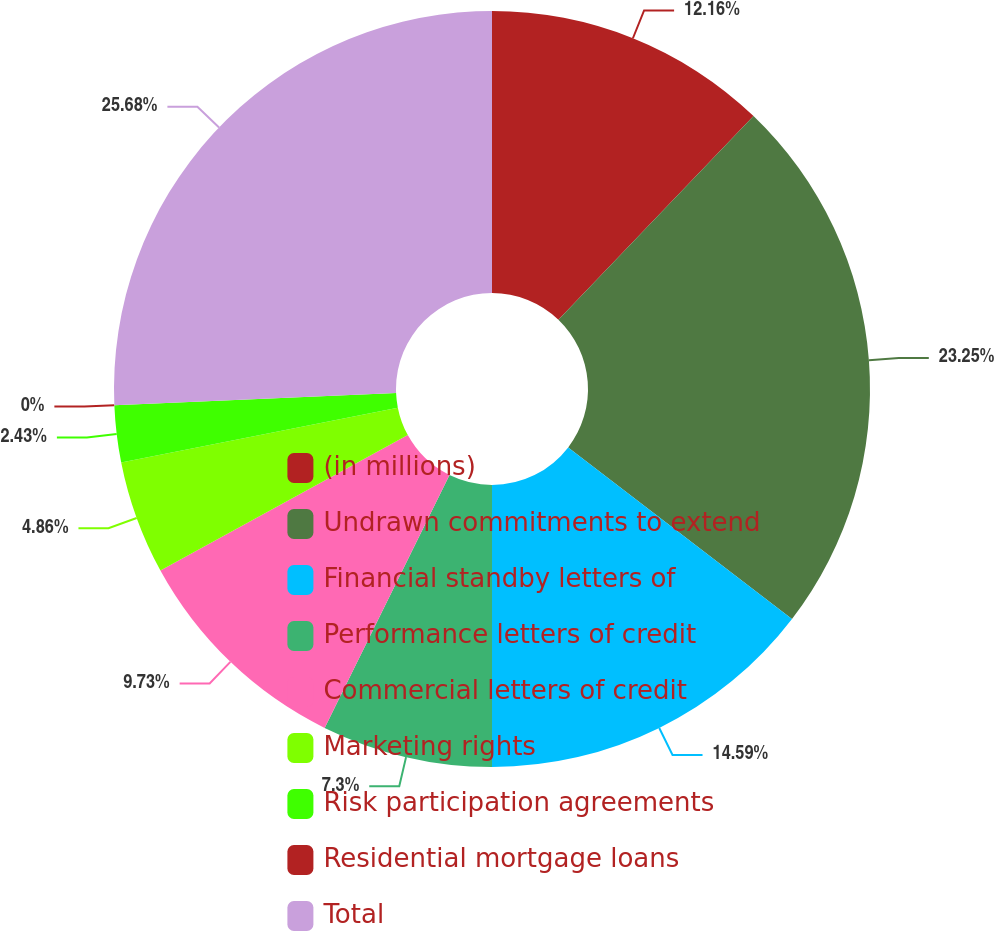<chart> <loc_0><loc_0><loc_500><loc_500><pie_chart><fcel>(in millions)<fcel>Undrawn commitments to extend<fcel>Financial standby letters of<fcel>Performance letters of credit<fcel>Commercial letters of credit<fcel>Marketing rights<fcel>Risk participation agreements<fcel>Residential mortgage loans<fcel>Total<nl><fcel>12.16%<fcel>23.25%<fcel>14.59%<fcel>7.3%<fcel>9.73%<fcel>4.86%<fcel>2.43%<fcel>0.0%<fcel>25.68%<nl></chart> 